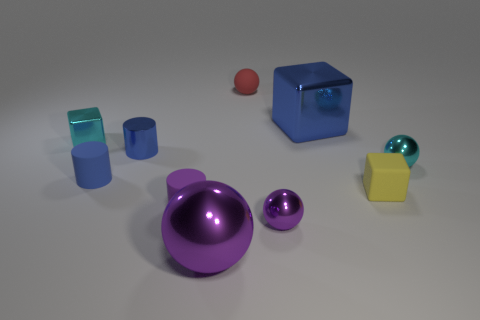Are there any big purple shiny things that have the same shape as the red matte object?
Keep it short and to the point. Yes. Is the color of the large cube the same as the matte cylinder that is behind the tiny matte block?
Offer a terse response. Yes. What is the size of the shiny thing that is the same color as the large metal sphere?
Offer a very short reply. Small. Is there a green cylinder of the same size as the cyan shiny cube?
Provide a short and direct response. No. Are the red ball and the tiny cyan cube behind the tiny blue shiny cylinder made of the same material?
Your response must be concise. No. Are there more small red matte objects than tiny yellow rubber cylinders?
Ensure brevity in your answer.  Yes. How many cylinders are shiny objects or blue shiny objects?
Ensure brevity in your answer.  1. What color is the large ball?
Provide a short and direct response. Purple. Does the cyan object right of the blue rubber cylinder have the same size as the shiny cube to the right of the small purple rubber cylinder?
Provide a short and direct response. No. Are there fewer tiny cyan rubber cylinders than cyan cubes?
Offer a terse response. Yes. 